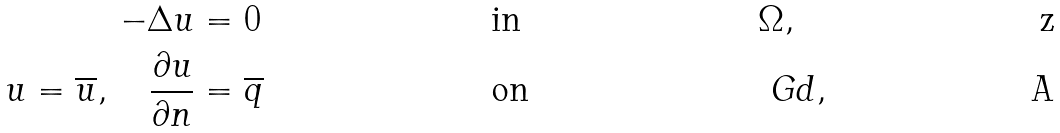Convert formula to latex. <formula><loc_0><loc_0><loc_500><loc_500>- \Delta u & = 0 & & \text {in} & & \Omega , \\ u = \overline { u } , \quad \frac { \partial u } { \partial n } & = \overline { q } & & \text {on} & & \ G d ,</formula> 